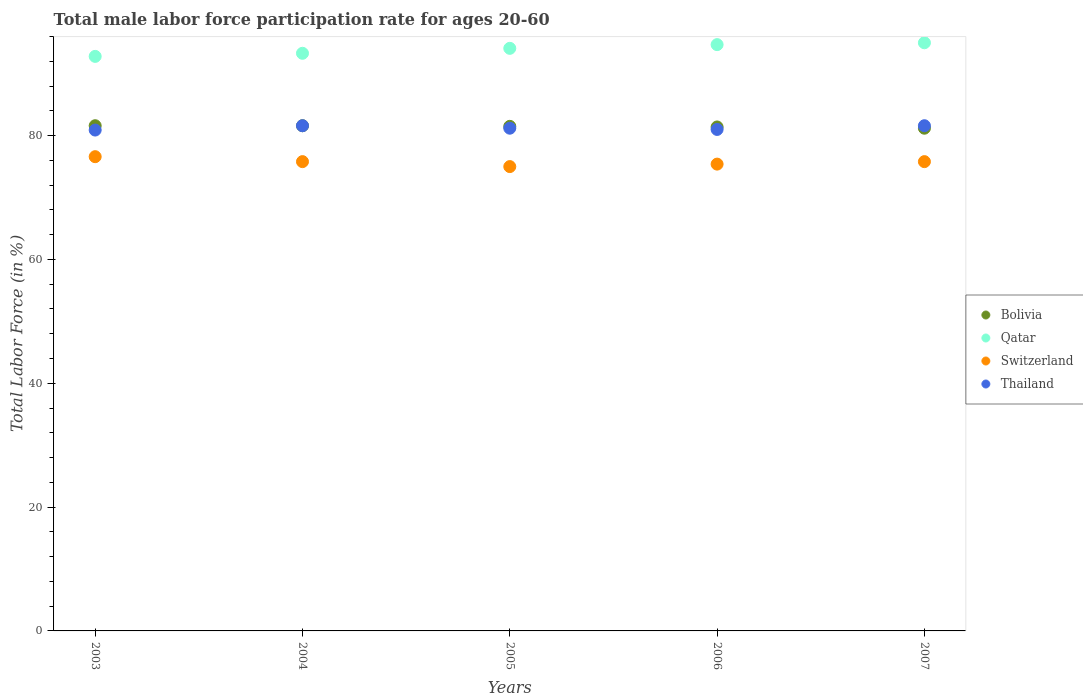How many different coloured dotlines are there?
Your response must be concise. 4. What is the male labor force participation rate in Bolivia in 2003?
Your answer should be very brief. 81.6. Across all years, what is the minimum male labor force participation rate in Bolivia?
Offer a terse response. 81.2. In which year was the male labor force participation rate in Bolivia maximum?
Make the answer very short. 2003. What is the total male labor force participation rate in Qatar in the graph?
Your answer should be very brief. 469.9. What is the difference between the male labor force participation rate in Qatar in 2004 and that in 2005?
Your response must be concise. -0.8. What is the difference between the male labor force participation rate in Thailand in 2004 and the male labor force participation rate in Bolivia in 2005?
Your answer should be compact. 0.1. What is the average male labor force participation rate in Bolivia per year?
Your answer should be very brief. 81.46. In the year 2006, what is the difference between the male labor force participation rate in Qatar and male labor force participation rate in Thailand?
Offer a very short reply. 13.7. In how many years, is the male labor force participation rate in Qatar greater than 24 %?
Provide a succinct answer. 5. What is the ratio of the male labor force participation rate in Qatar in 2003 to that in 2007?
Your answer should be compact. 0.98. Is the male labor force participation rate in Switzerland in 2003 less than that in 2007?
Your answer should be compact. No. What is the difference between the highest and the second highest male labor force participation rate in Thailand?
Your answer should be very brief. 0. What is the difference between the highest and the lowest male labor force participation rate in Switzerland?
Make the answer very short. 1.6. Is the sum of the male labor force participation rate in Thailand in 2003 and 2007 greater than the maximum male labor force participation rate in Qatar across all years?
Your response must be concise. Yes. Is it the case that in every year, the sum of the male labor force participation rate in Bolivia and male labor force participation rate in Qatar  is greater than the sum of male labor force participation rate in Thailand and male labor force participation rate in Switzerland?
Provide a succinct answer. Yes. Is the male labor force participation rate in Bolivia strictly less than the male labor force participation rate in Qatar over the years?
Keep it short and to the point. Yes. How many dotlines are there?
Keep it short and to the point. 4. Does the graph contain grids?
Provide a succinct answer. No. Where does the legend appear in the graph?
Your answer should be very brief. Center right. What is the title of the graph?
Offer a terse response. Total male labor force participation rate for ages 20-60. What is the Total Labor Force (in %) of Bolivia in 2003?
Give a very brief answer. 81.6. What is the Total Labor Force (in %) in Qatar in 2003?
Provide a short and direct response. 92.8. What is the Total Labor Force (in %) in Switzerland in 2003?
Your response must be concise. 76.6. What is the Total Labor Force (in %) of Thailand in 2003?
Your answer should be very brief. 80.9. What is the Total Labor Force (in %) of Bolivia in 2004?
Your answer should be very brief. 81.6. What is the Total Labor Force (in %) of Qatar in 2004?
Your answer should be very brief. 93.3. What is the Total Labor Force (in %) of Switzerland in 2004?
Provide a succinct answer. 75.8. What is the Total Labor Force (in %) in Thailand in 2004?
Offer a terse response. 81.6. What is the Total Labor Force (in %) in Bolivia in 2005?
Your response must be concise. 81.5. What is the Total Labor Force (in %) of Qatar in 2005?
Provide a succinct answer. 94.1. What is the Total Labor Force (in %) in Switzerland in 2005?
Give a very brief answer. 75. What is the Total Labor Force (in %) in Thailand in 2005?
Offer a very short reply. 81.2. What is the Total Labor Force (in %) of Bolivia in 2006?
Your answer should be very brief. 81.4. What is the Total Labor Force (in %) of Qatar in 2006?
Provide a succinct answer. 94.7. What is the Total Labor Force (in %) in Switzerland in 2006?
Keep it short and to the point. 75.4. What is the Total Labor Force (in %) in Bolivia in 2007?
Your answer should be compact. 81.2. What is the Total Labor Force (in %) of Switzerland in 2007?
Give a very brief answer. 75.8. What is the Total Labor Force (in %) of Thailand in 2007?
Your response must be concise. 81.6. Across all years, what is the maximum Total Labor Force (in %) of Bolivia?
Make the answer very short. 81.6. Across all years, what is the maximum Total Labor Force (in %) in Qatar?
Give a very brief answer. 95. Across all years, what is the maximum Total Labor Force (in %) of Switzerland?
Offer a very short reply. 76.6. Across all years, what is the maximum Total Labor Force (in %) in Thailand?
Your response must be concise. 81.6. Across all years, what is the minimum Total Labor Force (in %) of Bolivia?
Your answer should be compact. 81.2. Across all years, what is the minimum Total Labor Force (in %) of Qatar?
Your answer should be compact. 92.8. Across all years, what is the minimum Total Labor Force (in %) in Thailand?
Provide a succinct answer. 80.9. What is the total Total Labor Force (in %) of Bolivia in the graph?
Give a very brief answer. 407.3. What is the total Total Labor Force (in %) in Qatar in the graph?
Your answer should be compact. 469.9. What is the total Total Labor Force (in %) in Switzerland in the graph?
Offer a very short reply. 378.6. What is the total Total Labor Force (in %) of Thailand in the graph?
Make the answer very short. 406.3. What is the difference between the Total Labor Force (in %) of Qatar in 2003 and that in 2004?
Your response must be concise. -0.5. What is the difference between the Total Labor Force (in %) in Switzerland in 2003 and that in 2004?
Offer a very short reply. 0.8. What is the difference between the Total Labor Force (in %) of Thailand in 2003 and that in 2005?
Give a very brief answer. -0.3. What is the difference between the Total Labor Force (in %) in Bolivia in 2003 and that in 2006?
Offer a very short reply. 0.2. What is the difference between the Total Labor Force (in %) in Qatar in 2003 and that in 2006?
Provide a succinct answer. -1.9. What is the difference between the Total Labor Force (in %) in Switzerland in 2003 and that in 2006?
Make the answer very short. 1.2. What is the difference between the Total Labor Force (in %) in Qatar in 2003 and that in 2007?
Provide a succinct answer. -2.2. What is the difference between the Total Labor Force (in %) in Qatar in 2004 and that in 2005?
Your response must be concise. -0.8. What is the difference between the Total Labor Force (in %) of Thailand in 2004 and that in 2005?
Keep it short and to the point. 0.4. What is the difference between the Total Labor Force (in %) in Switzerland in 2004 and that in 2006?
Your answer should be very brief. 0.4. What is the difference between the Total Labor Force (in %) of Thailand in 2004 and that in 2006?
Your answer should be very brief. 0.6. What is the difference between the Total Labor Force (in %) in Switzerland in 2004 and that in 2007?
Provide a succinct answer. 0. What is the difference between the Total Labor Force (in %) of Thailand in 2004 and that in 2007?
Make the answer very short. 0. What is the difference between the Total Labor Force (in %) in Switzerland in 2005 and that in 2006?
Make the answer very short. -0.4. What is the difference between the Total Labor Force (in %) in Thailand in 2005 and that in 2006?
Your response must be concise. 0.2. What is the difference between the Total Labor Force (in %) in Qatar in 2005 and that in 2007?
Make the answer very short. -0.9. What is the difference between the Total Labor Force (in %) of Bolivia in 2006 and that in 2007?
Offer a very short reply. 0.2. What is the difference between the Total Labor Force (in %) of Thailand in 2006 and that in 2007?
Make the answer very short. -0.6. What is the difference between the Total Labor Force (in %) of Bolivia in 2003 and the Total Labor Force (in %) of Qatar in 2004?
Ensure brevity in your answer.  -11.7. What is the difference between the Total Labor Force (in %) in Bolivia in 2003 and the Total Labor Force (in %) in Switzerland in 2004?
Ensure brevity in your answer.  5.8. What is the difference between the Total Labor Force (in %) of Bolivia in 2003 and the Total Labor Force (in %) of Qatar in 2005?
Keep it short and to the point. -12.5. What is the difference between the Total Labor Force (in %) in Bolivia in 2003 and the Total Labor Force (in %) in Switzerland in 2005?
Offer a terse response. 6.6. What is the difference between the Total Labor Force (in %) in Qatar in 2003 and the Total Labor Force (in %) in Switzerland in 2005?
Ensure brevity in your answer.  17.8. What is the difference between the Total Labor Force (in %) in Qatar in 2003 and the Total Labor Force (in %) in Thailand in 2005?
Offer a terse response. 11.6. What is the difference between the Total Labor Force (in %) in Qatar in 2003 and the Total Labor Force (in %) in Thailand in 2006?
Offer a very short reply. 11.8. What is the difference between the Total Labor Force (in %) of Bolivia in 2003 and the Total Labor Force (in %) of Switzerland in 2007?
Ensure brevity in your answer.  5.8. What is the difference between the Total Labor Force (in %) of Bolivia in 2004 and the Total Labor Force (in %) of Switzerland in 2005?
Ensure brevity in your answer.  6.6. What is the difference between the Total Labor Force (in %) in Qatar in 2004 and the Total Labor Force (in %) in Thailand in 2005?
Your response must be concise. 12.1. What is the difference between the Total Labor Force (in %) in Switzerland in 2004 and the Total Labor Force (in %) in Thailand in 2005?
Give a very brief answer. -5.4. What is the difference between the Total Labor Force (in %) in Qatar in 2004 and the Total Labor Force (in %) in Thailand in 2006?
Provide a short and direct response. 12.3. What is the difference between the Total Labor Force (in %) of Bolivia in 2004 and the Total Labor Force (in %) of Switzerland in 2007?
Ensure brevity in your answer.  5.8. What is the difference between the Total Labor Force (in %) in Bolivia in 2004 and the Total Labor Force (in %) in Thailand in 2007?
Your answer should be compact. 0. What is the difference between the Total Labor Force (in %) of Qatar in 2004 and the Total Labor Force (in %) of Switzerland in 2007?
Ensure brevity in your answer.  17.5. What is the difference between the Total Labor Force (in %) in Switzerland in 2004 and the Total Labor Force (in %) in Thailand in 2007?
Make the answer very short. -5.8. What is the difference between the Total Labor Force (in %) in Bolivia in 2005 and the Total Labor Force (in %) in Switzerland in 2006?
Your response must be concise. 6.1. What is the difference between the Total Labor Force (in %) in Bolivia in 2005 and the Total Labor Force (in %) in Thailand in 2006?
Keep it short and to the point. 0.5. What is the difference between the Total Labor Force (in %) of Qatar in 2005 and the Total Labor Force (in %) of Switzerland in 2006?
Your answer should be compact. 18.7. What is the difference between the Total Labor Force (in %) in Qatar in 2005 and the Total Labor Force (in %) in Thailand in 2006?
Keep it short and to the point. 13.1. What is the difference between the Total Labor Force (in %) of Switzerland in 2005 and the Total Labor Force (in %) of Thailand in 2006?
Make the answer very short. -6. What is the difference between the Total Labor Force (in %) of Bolivia in 2005 and the Total Labor Force (in %) of Switzerland in 2007?
Your response must be concise. 5.7. What is the difference between the Total Labor Force (in %) in Qatar in 2005 and the Total Labor Force (in %) in Thailand in 2007?
Ensure brevity in your answer.  12.5. What is the difference between the Total Labor Force (in %) of Bolivia in 2006 and the Total Labor Force (in %) of Switzerland in 2007?
Give a very brief answer. 5.6. What is the difference between the Total Labor Force (in %) of Bolivia in 2006 and the Total Labor Force (in %) of Thailand in 2007?
Provide a succinct answer. -0.2. What is the difference between the Total Labor Force (in %) of Qatar in 2006 and the Total Labor Force (in %) of Switzerland in 2007?
Your response must be concise. 18.9. What is the difference between the Total Labor Force (in %) in Qatar in 2006 and the Total Labor Force (in %) in Thailand in 2007?
Your answer should be compact. 13.1. What is the difference between the Total Labor Force (in %) in Switzerland in 2006 and the Total Labor Force (in %) in Thailand in 2007?
Your response must be concise. -6.2. What is the average Total Labor Force (in %) of Bolivia per year?
Give a very brief answer. 81.46. What is the average Total Labor Force (in %) of Qatar per year?
Give a very brief answer. 93.98. What is the average Total Labor Force (in %) of Switzerland per year?
Your response must be concise. 75.72. What is the average Total Labor Force (in %) in Thailand per year?
Your answer should be very brief. 81.26. In the year 2003, what is the difference between the Total Labor Force (in %) of Bolivia and Total Labor Force (in %) of Qatar?
Your answer should be very brief. -11.2. In the year 2003, what is the difference between the Total Labor Force (in %) in Bolivia and Total Labor Force (in %) in Thailand?
Provide a short and direct response. 0.7. In the year 2003, what is the difference between the Total Labor Force (in %) of Qatar and Total Labor Force (in %) of Switzerland?
Your answer should be very brief. 16.2. In the year 2003, what is the difference between the Total Labor Force (in %) of Qatar and Total Labor Force (in %) of Thailand?
Your response must be concise. 11.9. In the year 2003, what is the difference between the Total Labor Force (in %) of Switzerland and Total Labor Force (in %) of Thailand?
Give a very brief answer. -4.3. In the year 2004, what is the difference between the Total Labor Force (in %) in Qatar and Total Labor Force (in %) in Thailand?
Your answer should be very brief. 11.7. In the year 2005, what is the difference between the Total Labor Force (in %) of Bolivia and Total Labor Force (in %) of Switzerland?
Keep it short and to the point. 6.5. In the year 2005, what is the difference between the Total Labor Force (in %) in Qatar and Total Labor Force (in %) in Thailand?
Keep it short and to the point. 12.9. In the year 2006, what is the difference between the Total Labor Force (in %) of Bolivia and Total Labor Force (in %) of Switzerland?
Provide a short and direct response. 6. In the year 2006, what is the difference between the Total Labor Force (in %) of Qatar and Total Labor Force (in %) of Switzerland?
Keep it short and to the point. 19.3. In the year 2006, what is the difference between the Total Labor Force (in %) in Qatar and Total Labor Force (in %) in Thailand?
Your answer should be compact. 13.7. In the year 2006, what is the difference between the Total Labor Force (in %) of Switzerland and Total Labor Force (in %) of Thailand?
Your answer should be compact. -5.6. In the year 2007, what is the difference between the Total Labor Force (in %) of Bolivia and Total Labor Force (in %) of Qatar?
Your answer should be very brief. -13.8. In the year 2007, what is the difference between the Total Labor Force (in %) of Bolivia and Total Labor Force (in %) of Thailand?
Provide a succinct answer. -0.4. In the year 2007, what is the difference between the Total Labor Force (in %) in Qatar and Total Labor Force (in %) in Switzerland?
Provide a succinct answer. 19.2. In the year 2007, what is the difference between the Total Labor Force (in %) of Qatar and Total Labor Force (in %) of Thailand?
Offer a very short reply. 13.4. What is the ratio of the Total Labor Force (in %) of Bolivia in 2003 to that in 2004?
Keep it short and to the point. 1. What is the ratio of the Total Labor Force (in %) of Switzerland in 2003 to that in 2004?
Give a very brief answer. 1.01. What is the ratio of the Total Labor Force (in %) in Bolivia in 2003 to that in 2005?
Provide a succinct answer. 1. What is the ratio of the Total Labor Force (in %) of Qatar in 2003 to that in 2005?
Ensure brevity in your answer.  0.99. What is the ratio of the Total Labor Force (in %) in Switzerland in 2003 to that in 2005?
Ensure brevity in your answer.  1.02. What is the ratio of the Total Labor Force (in %) of Qatar in 2003 to that in 2006?
Provide a succinct answer. 0.98. What is the ratio of the Total Labor Force (in %) in Switzerland in 2003 to that in 2006?
Offer a very short reply. 1.02. What is the ratio of the Total Labor Force (in %) of Thailand in 2003 to that in 2006?
Your response must be concise. 1. What is the ratio of the Total Labor Force (in %) in Qatar in 2003 to that in 2007?
Provide a succinct answer. 0.98. What is the ratio of the Total Labor Force (in %) in Switzerland in 2003 to that in 2007?
Make the answer very short. 1.01. What is the ratio of the Total Labor Force (in %) of Thailand in 2003 to that in 2007?
Provide a succinct answer. 0.99. What is the ratio of the Total Labor Force (in %) in Bolivia in 2004 to that in 2005?
Offer a terse response. 1. What is the ratio of the Total Labor Force (in %) in Qatar in 2004 to that in 2005?
Ensure brevity in your answer.  0.99. What is the ratio of the Total Labor Force (in %) in Switzerland in 2004 to that in 2005?
Give a very brief answer. 1.01. What is the ratio of the Total Labor Force (in %) of Thailand in 2004 to that in 2005?
Keep it short and to the point. 1. What is the ratio of the Total Labor Force (in %) of Qatar in 2004 to that in 2006?
Provide a short and direct response. 0.99. What is the ratio of the Total Labor Force (in %) of Switzerland in 2004 to that in 2006?
Ensure brevity in your answer.  1.01. What is the ratio of the Total Labor Force (in %) in Thailand in 2004 to that in 2006?
Offer a very short reply. 1.01. What is the ratio of the Total Labor Force (in %) of Qatar in 2004 to that in 2007?
Your answer should be compact. 0.98. What is the ratio of the Total Labor Force (in %) in Thailand in 2004 to that in 2007?
Provide a succinct answer. 1. What is the ratio of the Total Labor Force (in %) of Bolivia in 2005 to that in 2006?
Offer a very short reply. 1. What is the ratio of the Total Labor Force (in %) of Switzerland in 2005 to that in 2006?
Your answer should be compact. 0.99. What is the ratio of the Total Labor Force (in %) in Thailand in 2005 to that in 2006?
Provide a short and direct response. 1. What is the ratio of the Total Labor Force (in %) of Qatar in 2005 to that in 2007?
Offer a terse response. 0.99. What is the ratio of the Total Labor Force (in %) in Bolivia in 2006 to that in 2007?
Your answer should be compact. 1. What is the ratio of the Total Labor Force (in %) of Qatar in 2006 to that in 2007?
Provide a short and direct response. 1. What is the ratio of the Total Labor Force (in %) in Thailand in 2006 to that in 2007?
Offer a very short reply. 0.99. What is the difference between the highest and the second highest Total Labor Force (in %) in Bolivia?
Give a very brief answer. 0. What is the difference between the highest and the second highest Total Labor Force (in %) in Switzerland?
Offer a terse response. 0.8. What is the difference between the highest and the second highest Total Labor Force (in %) of Thailand?
Keep it short and to the point. 0. What is the difference between the highest and the lowest Total Labor Force (in %) of Qatar?
Give a very brief answer. 2.2. What is the difference between the highest and the lowest Total Labor Force (in %) in Thailand?
Your answer should be compact. 0.7. 